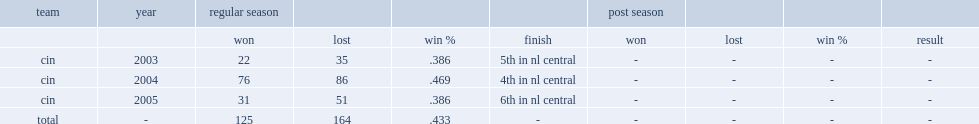What was the won-lost record that dave miley compiled in three seasons as the manager? 125.0 164.0. 